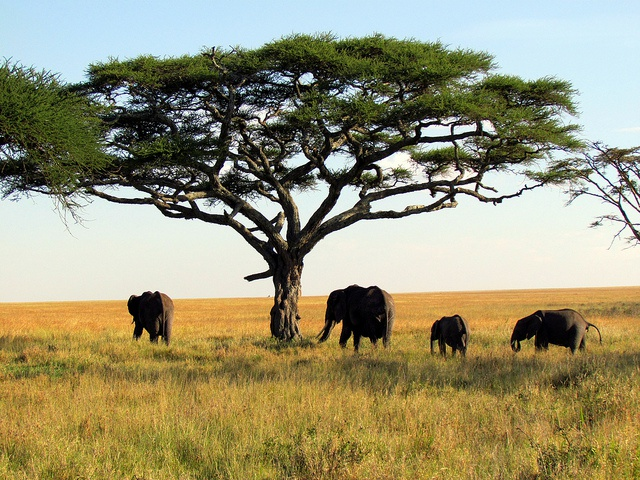Describe the objects in this image and their specific colors. I can see elephant in lightblue, black, olive, ivory, and gray tones, elephant in lightblue, black, olive, and maroon tones, elephant in lightblue, black, gray, olive, and maroon tones, and elephant in lightblue, black, olive, maroon, and gray tones in this image. 